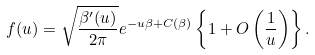<formula> <loc_0><loc_0><loc_500><loc_500>f ( u ) = \sqrt { \frac { \beta ^ { \prime } ( u ) } { 2 \pi } } e ^ { - u \beta + C ( \beta ) } \left \{ 1 + O \left ( \frac { 1 } { u } \right ) \right \} .</formula> 